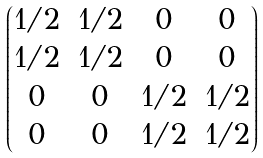Convert formula to latex. <formula><loc_0><loc_0><loc_500><loc_500>\begin{pmatrix} 1 / 2 & 1 / 2 & 0 & 0 \\ 1 / 2 & 1 / 2 & 0 & 0 \\ 0 & 0 & 1 / 2 & 1 / 2 \\ 0 & 0 & 1 / 2 & 1 / 2 \end{pmatrix}</formula> 